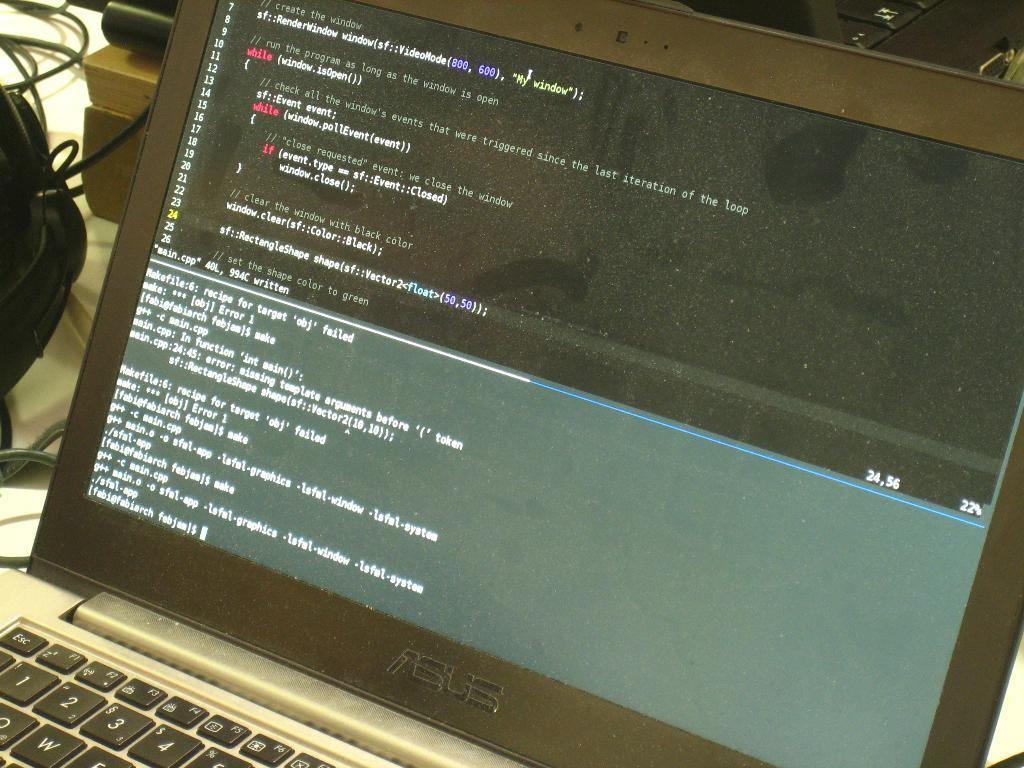What electronic device is present in the image? There is a laptop in the image. What can be seen on the laptop screen? There is text visible on the laptop screen. What else is present in the image besides the laptop? There are wires on the left side of the image. How many sheep can be seen grazing in the image? There are no sheep present in the image. Can you provide an example of the text visible on the laptop screen? Since we are not looking at the actual text on the laptop screen, we cannot provide an example of it. 